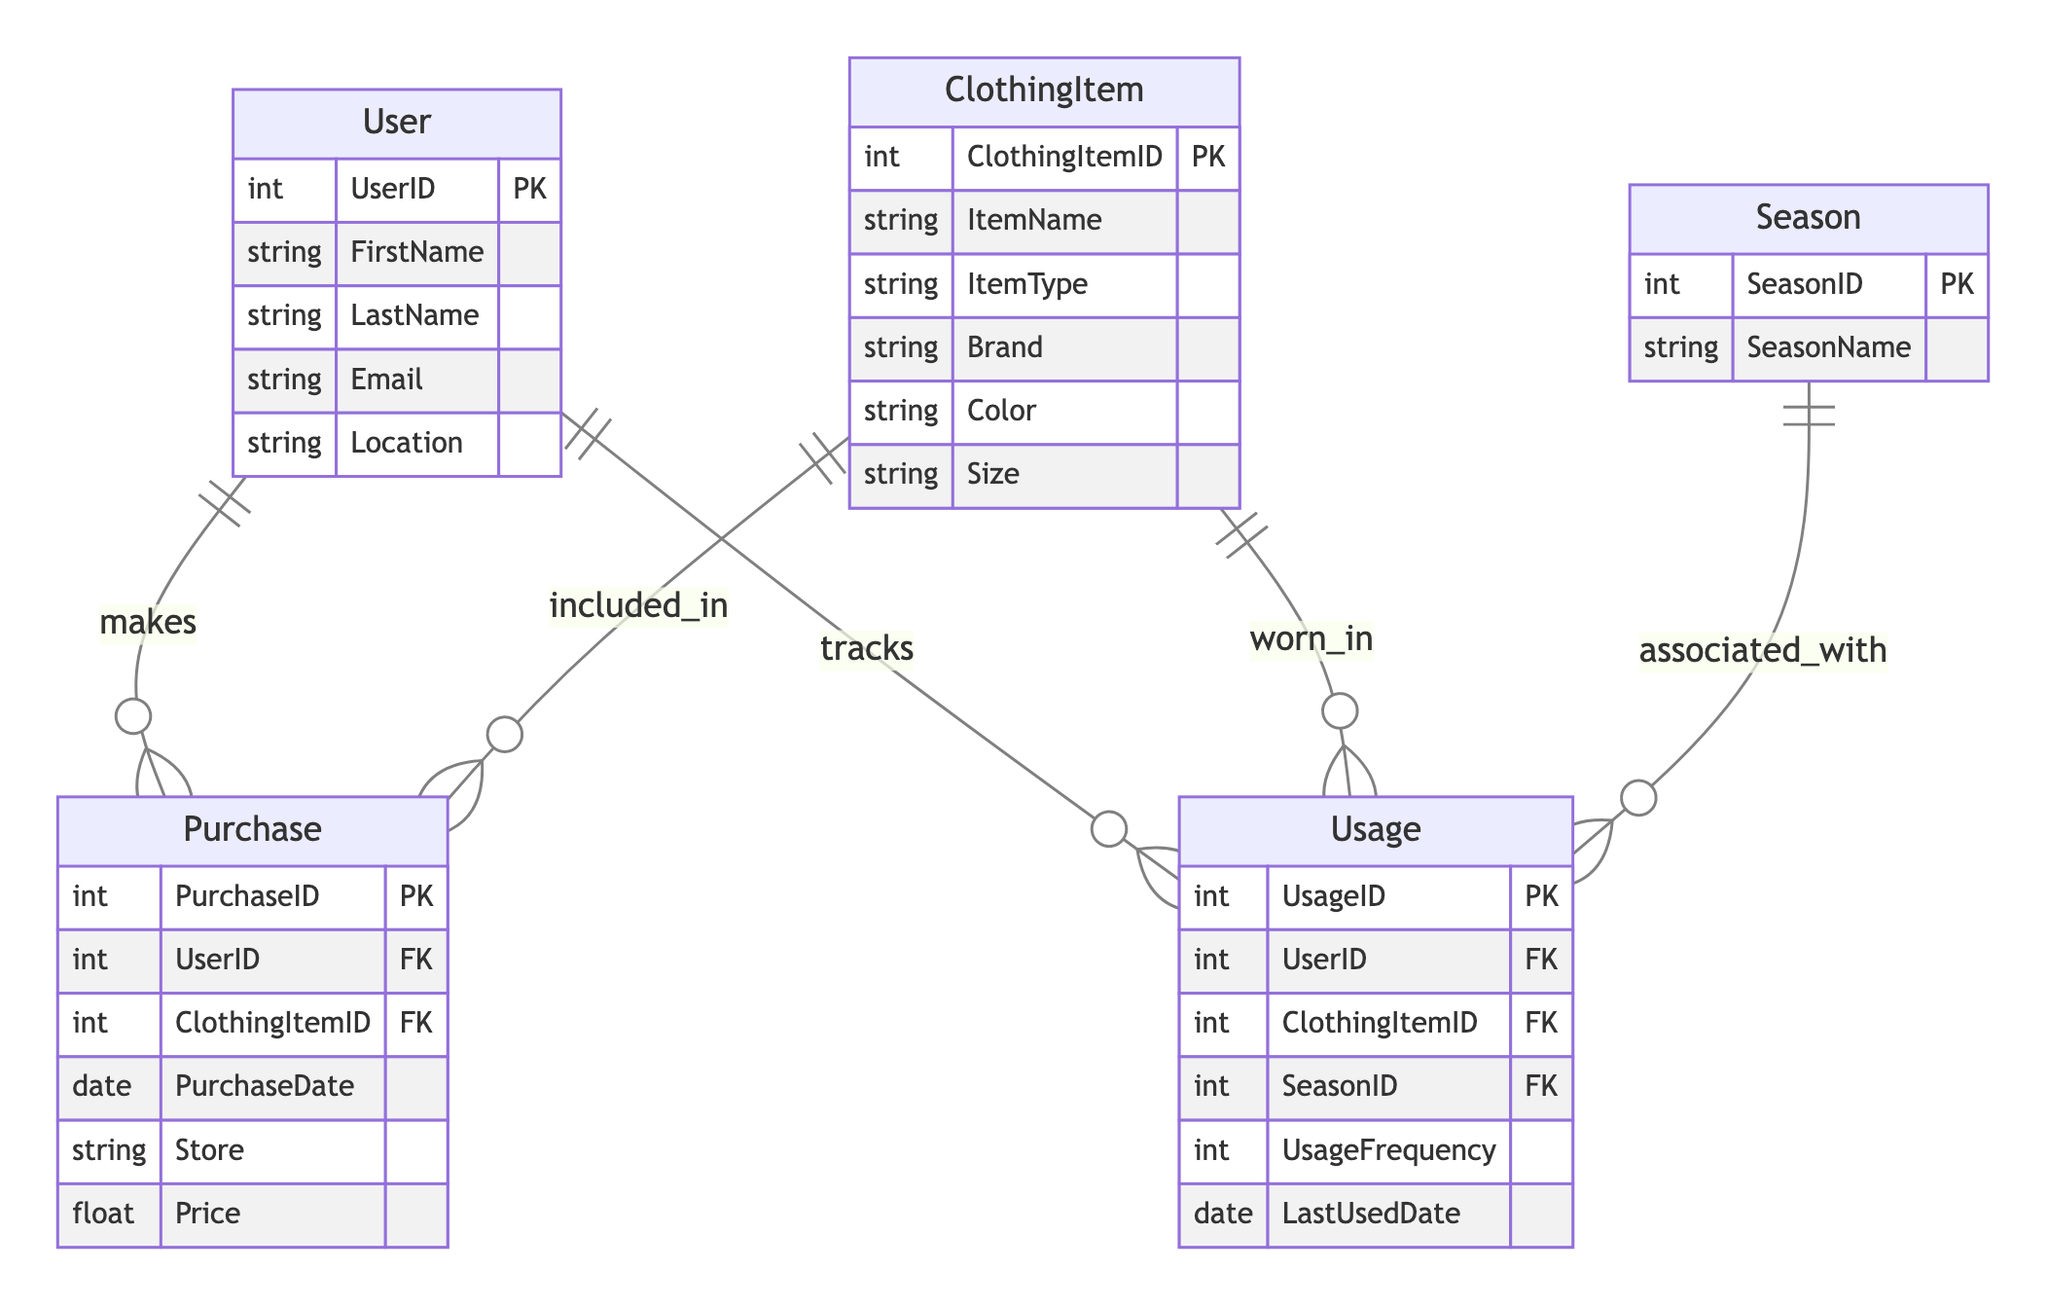What is the primary key of the User entity? The primary key of the User entity is listed as UserID in the attributes section of the entity.
Answer: UserID How many attributes does the Season entity have? The Season entity has two attributes: SeasonID and SeasonName. This can be counted from the attributes list in the entity.
Answer: 2 What is the foreign key in the Usage entity that references the Season entity? The foreign key in the Usage entity that references the Season entity is SeasonID, as indicated in the foreign_keys section of the Usage entity.
Answer: SeasonID How many entities are present in the diagram? There are five entities listed in the diagram: User, Season, ClothingItem, Purchase, and Usage. Each entity is distinct within the entities section.
Answer: 5 How many relationships are shown involving the User entity? The User entity is involved in two relationships: one with Purchase and one with Usage, which can be observed from the relationship lines connecting to the user entity.
Answer: 2 Which attribute of the ClothingItem entity specifies its size? The attribute that specifies the size of the ClothingItem is Size, as shown in the list of attributes for the ClothingItem entity.
Answer: Size In how many ways can a user track clothing usage? A user can track clothing usage in one way according to the diagram, which is through the Usage entity that connects back to the User entity.
Answer: 1 What type of information does the UsageFrequency attribute in the Usage entity represent? The UsageFrequency attribute represents how often a clothing item is used by the user, as inferred from the context of usage tracking in the diagram.
Answer: usage frequency 